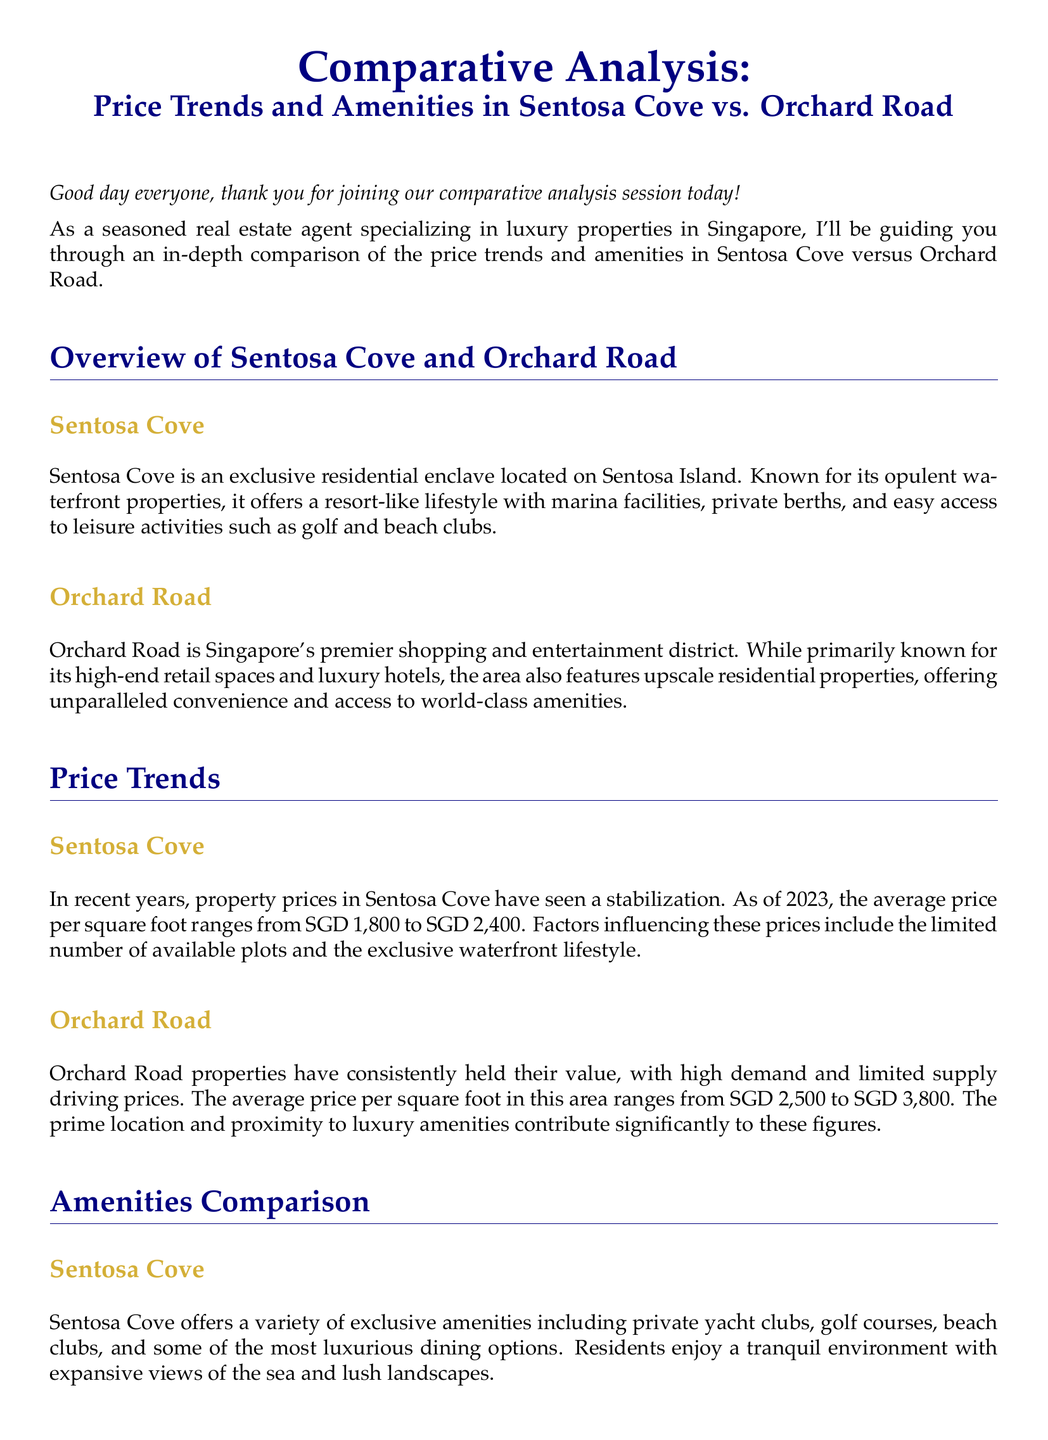What is the average price per square foot in Sentosa Cove? The document states that the average price per square foot in Sentosa Cove ranges from SGD 1,800 to SGD 2,400.
Answer: SGD 1,800 to SGD 2,400 What type of lifestyle does Sentosa Cove offer? According to the document, Sentosa Cove offers a resort-like lifestyle with marina facilities and private berths.
Answer: Resort-like lifestyle What are some of the high-end retail shopping malls mentioned for Orchard Road? The document lists ION Orchard and Paragon as high-end retail shopping malls in Orchard Road.
Answer: ION Orchard and Paragon What is the average price per square foot in Orchard Road? The document states that the average price per square foot in Orchard Road ranges from SGD 2,500 to SGD 3,800.
Answer: SGD 2,500 to SGD 3,800 Which area is described as having a tranquil environment with expansive views? The document indicates that Sentosa Cove has a tranquil environment with expansive views of the sea and lush landscapes.
Answer: Sentosa Cove What type of properties are primarily found in Orchard Road? The document mentions that Orchard Road features upscale residential properties.
Answer: Upscale residential properties What kind of dining options are available in Sentosa Cove? The document states that Sentosa Cove has luxurious dining options.
Answer: Luxurious dining options Which location is ideal for accessibility to premier shopping and dining? The document describes Orchard Road as ideal for accessibility to premier shopping and dining.
Answer: Orchard Road 